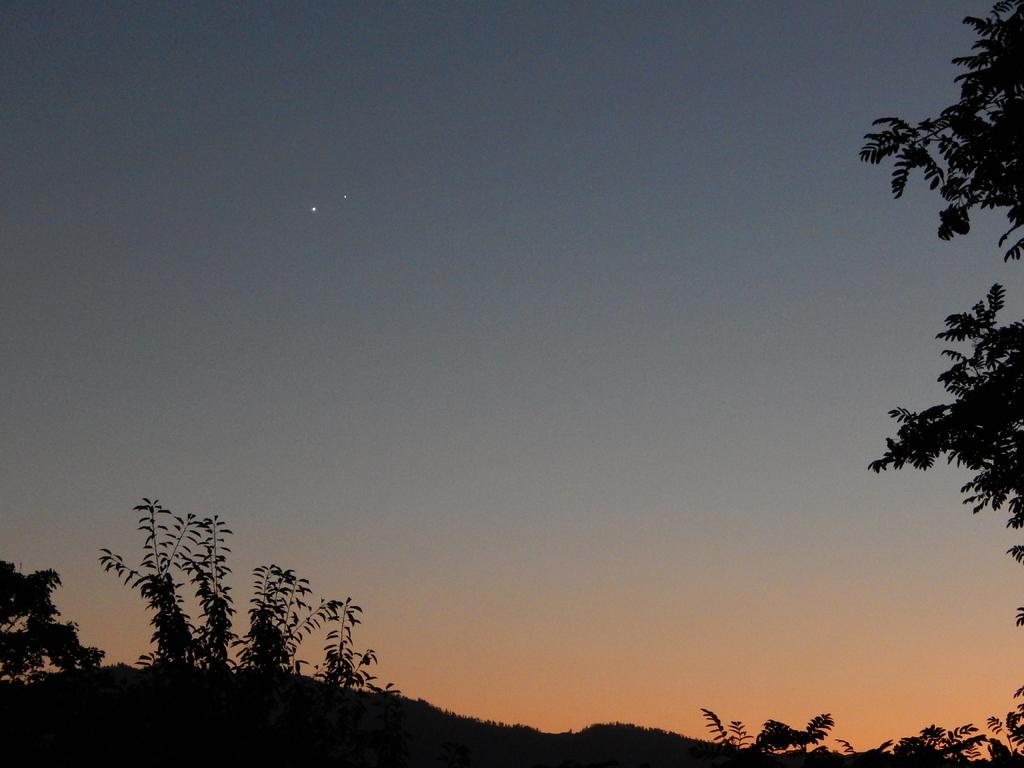What type of vegetation can be seen in the image? There are trees in the image. What part of the trees can be seen in the image? There are leaves in the image. What can be seen in the sky at the top of the image? Stars are visible in the sky at the top of the image. What type of advice does the representative give to the grandfather in the image? There is no representative or grandfather present in the image; it only features trees, leaves, and stars. 